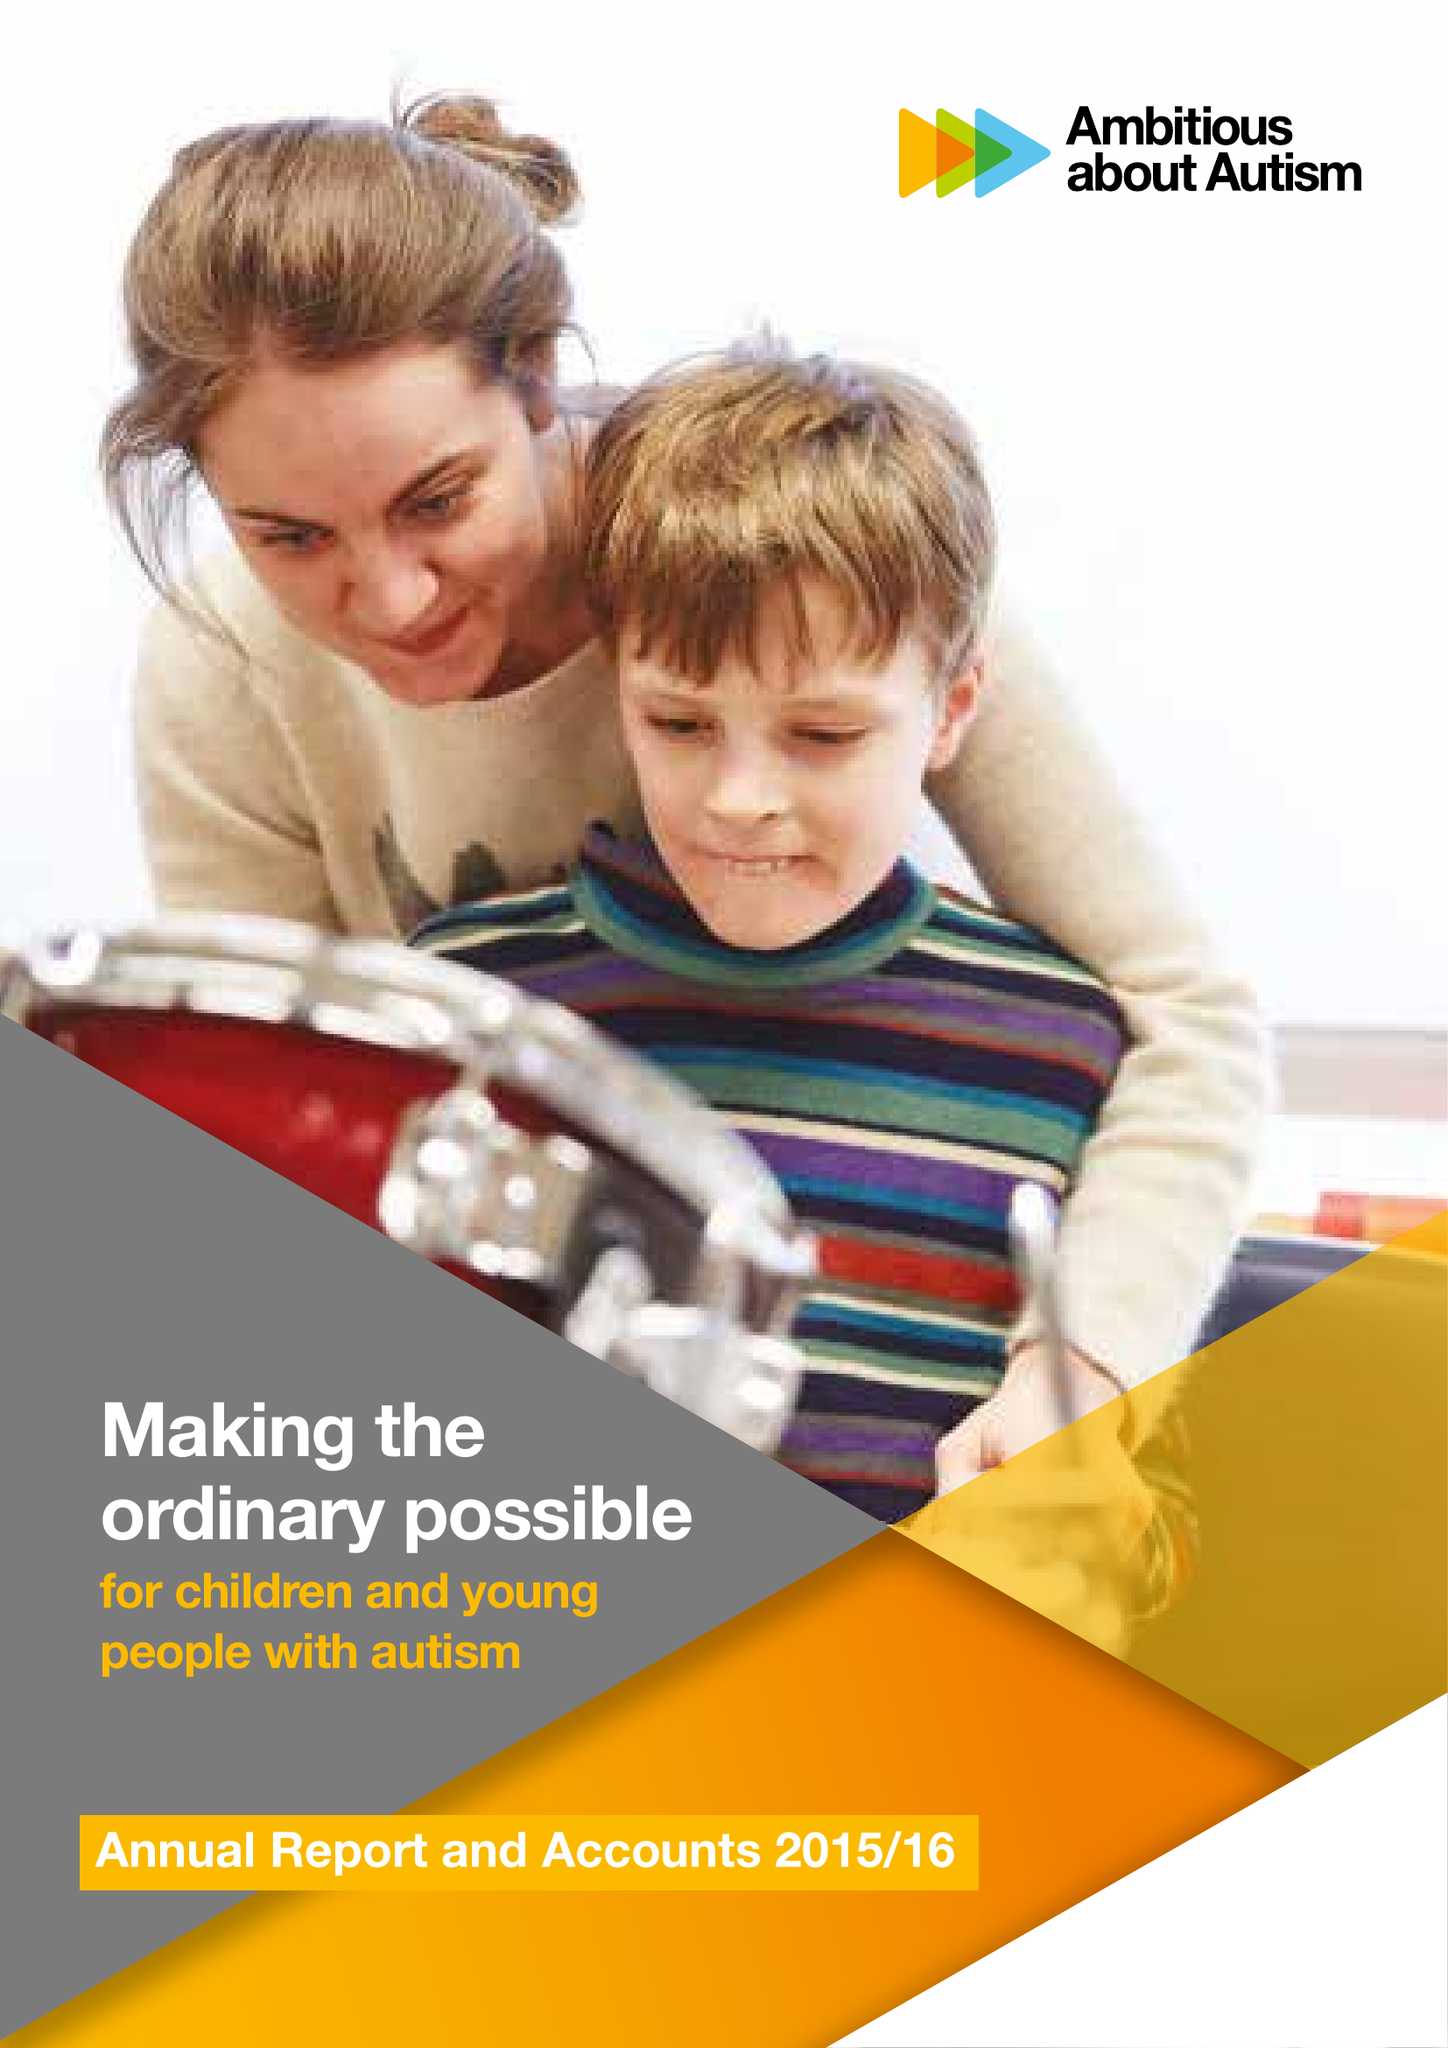What is the value for the spending_annually_in_british_pounds?
Answer the question using a single word or phrase. 11980000.00 